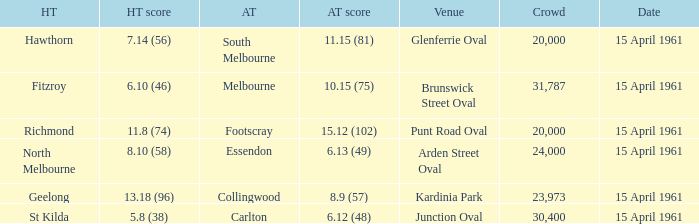What was the score for the home team St Kilda? 5.8 (38). 